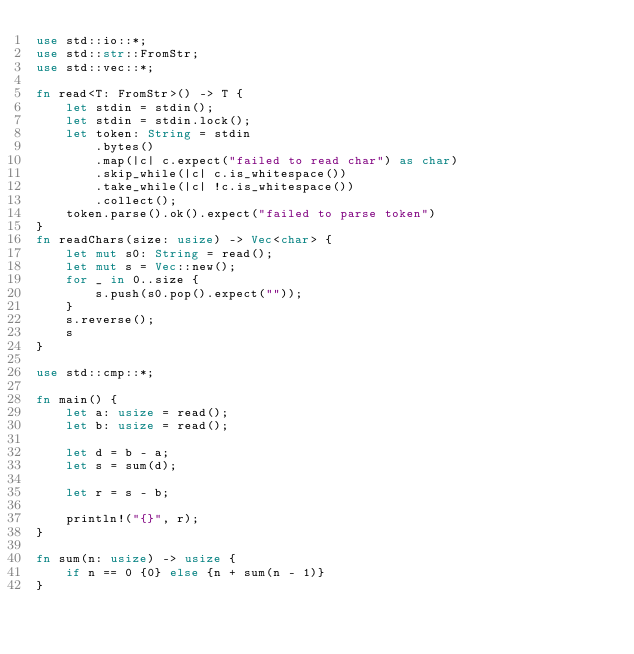Convert code to text. <code><loc_0><loc_0><loc_500><loc_500><_Rust_>use std::io::*;
use std::str::FromStr;
use std::vec::*;

fn read<T: FromStr>() -> T {
    let stdin = stdin();
    let stdin = stdin.lock();
    let token: String = stdin
        .bytes()
        .map(|c| c.expect("failed to read char") as char)
        .skip_while(|c| c.is_whitespace())
        .take_while(|c| !c.is_whitespace())
        .collect();
    token.parse().ok().expect("failed to parse token")
}
fn readChars(size: usize) -> Vec<char> {
    let mut s0: String = read();
    let mut s = Vec::new();
    for _ in 0..size {
        s.push(s0.pop().expect(""));
    }
    s.reverse();
    s
}

use std::cmp::*;

fn main() {
    let a: usize = read();
    let b: usize = read();

    let d = b - a;
    let s = sum(d);

    let r = s - b;

    println!("{}", r);
}

fn sum(n: usize) -> usize {
    if n == 0 {0} else {n + sum(n - 1)}
}
</code> 